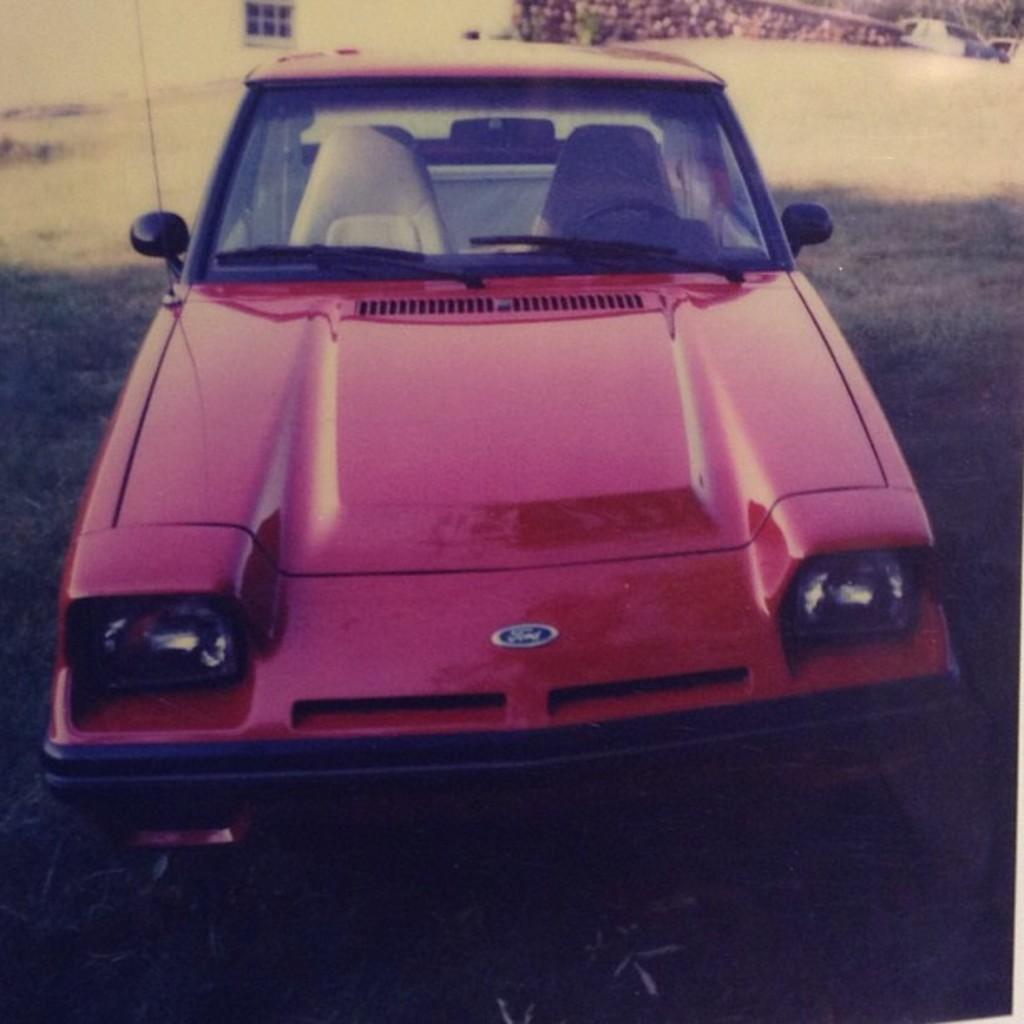How would you summarize this image in a sentence or two? In this image we can see a car which is placed on the ground. We can also see some grass. On the backside we can see a building with a window. 